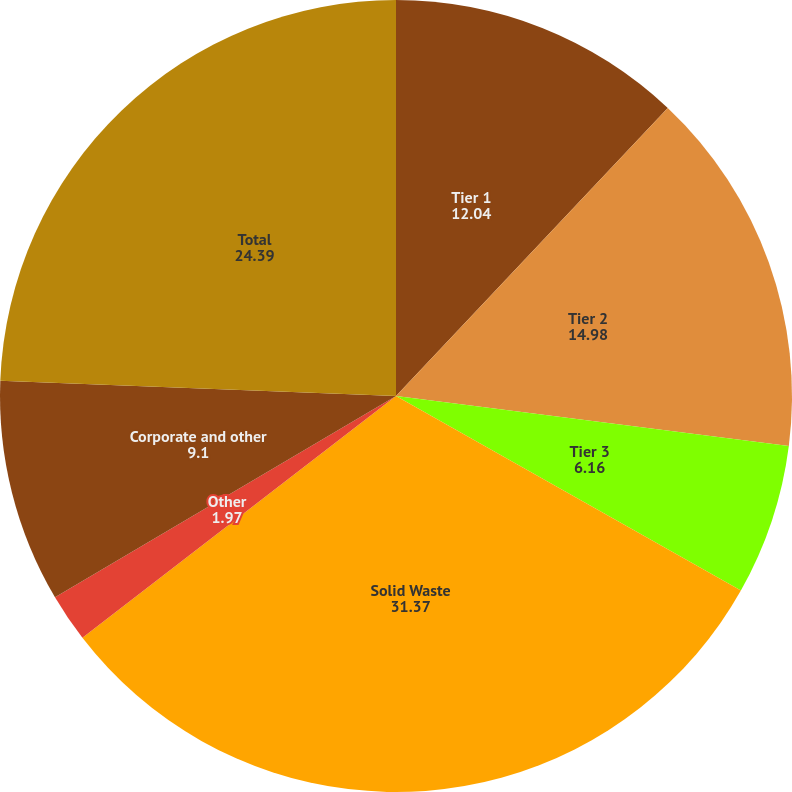<chart> <loc_0><loc_0><loc_500><loc_500><pie_chart><fcel>Tier 1<fcel>Tier 2<fcel>Tier 3<fcel>Solid Waste<fcel>Other<fcel>Corporate and other<fcel>Total<nl><fcel>12.04%<fcel>14.98%<fcel>6.16%<fcel>31.37%<fcel>1.97%<fcel>9.1%<fcel>24.39%<nl></chart> 